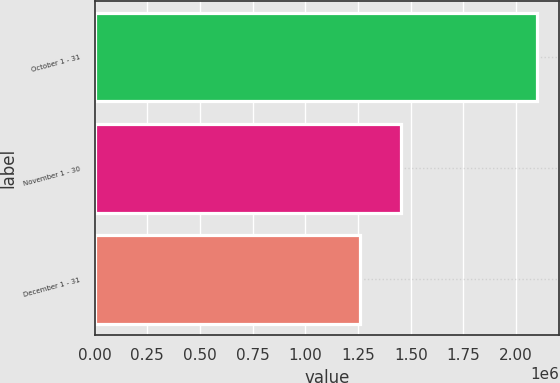Convert chart. <chart><loc_0><loc_0><loc_500><loc_500><bar_chart><fcel>October 1 - 31<fcel>November 1 - 30<fcel>December 1 - 31<nl><fcel>2.09917e+06<fcel>1.45305e+06<fcel>1.2587e+06<nl></chart> 